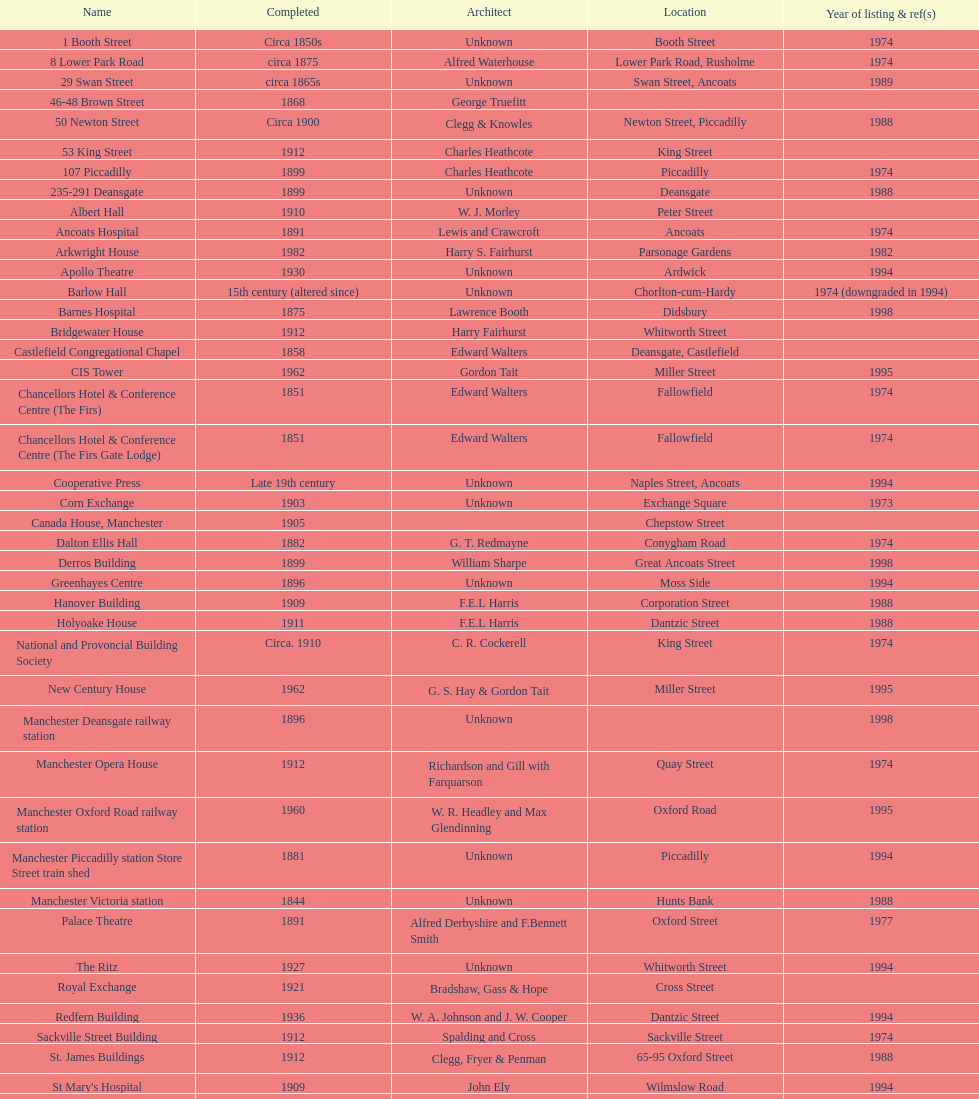Prior to 1974, what two structures were designated as listed buildings? The Old Wellington Inn, Smithfield Market Hall. 